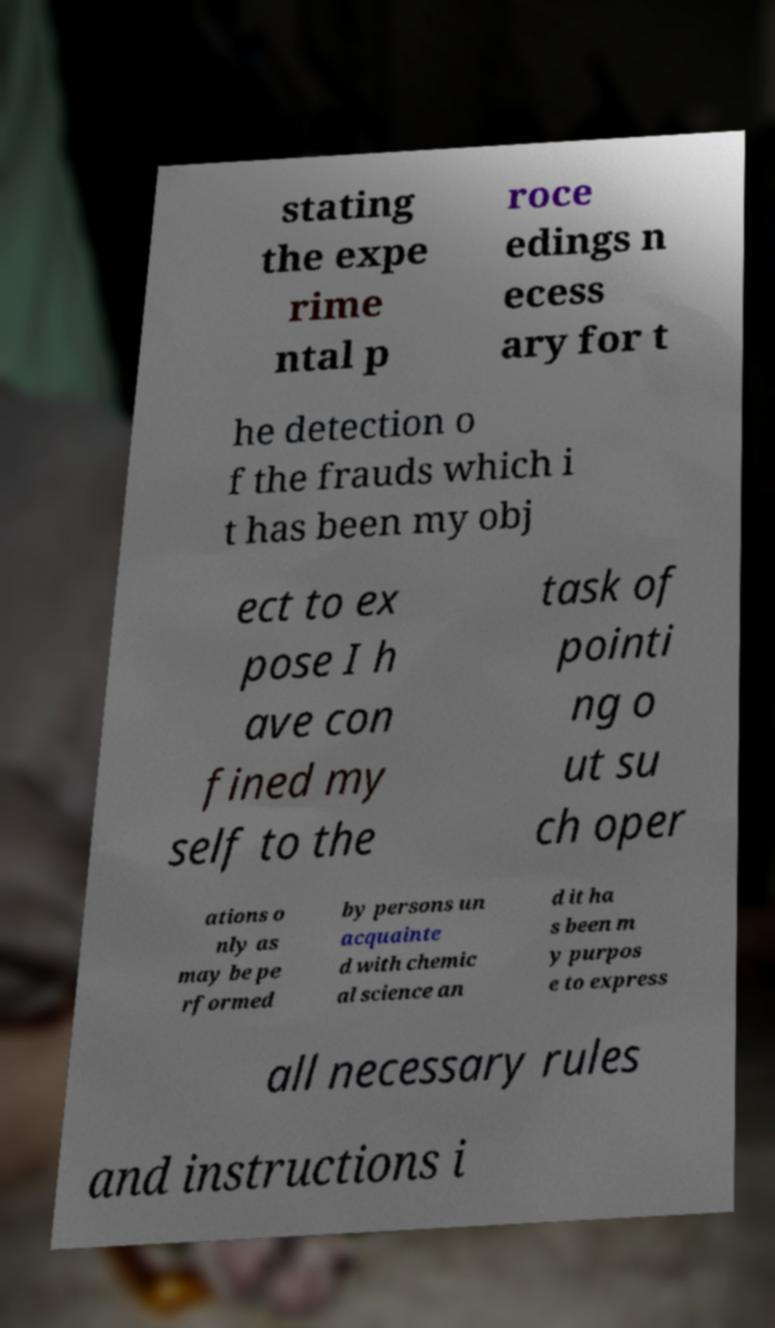Can you read and provide the text displayed in the image?This photo seems to have some interesting text. Can you extract and type it out for me? stating the expe rime ntal p roce edings n ecess ary for t he detection o f the frauds which i t has been my obj ect to ex pose I h ave con fined my self to the task of pointi ng o ut su ch oper ations o nly as may be pe rformed by persons un acquainte d with chemic al science an d it ha s been m y purpos e to express all necessary rules and instructions i 